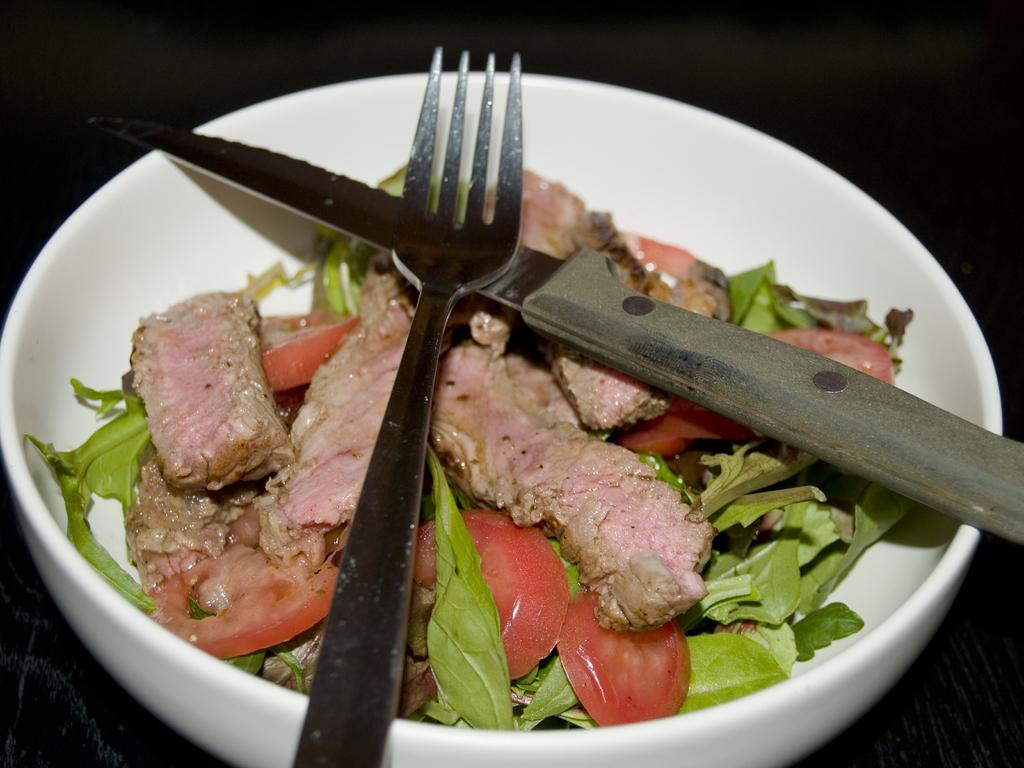What utensils are visible in the image? There is a fork and a knife in the image. What is the food in the image contained in? The food is in a bowl in the image. What can be observed about the background of the image? The background of the image is dark. What type of boot is hanging on the curtain in the image? There is no boot or curtain present in the image. What color is the wall behind the fork and knife in the image? The provided facts do not mention the color of the wall, only that the background is dark. 